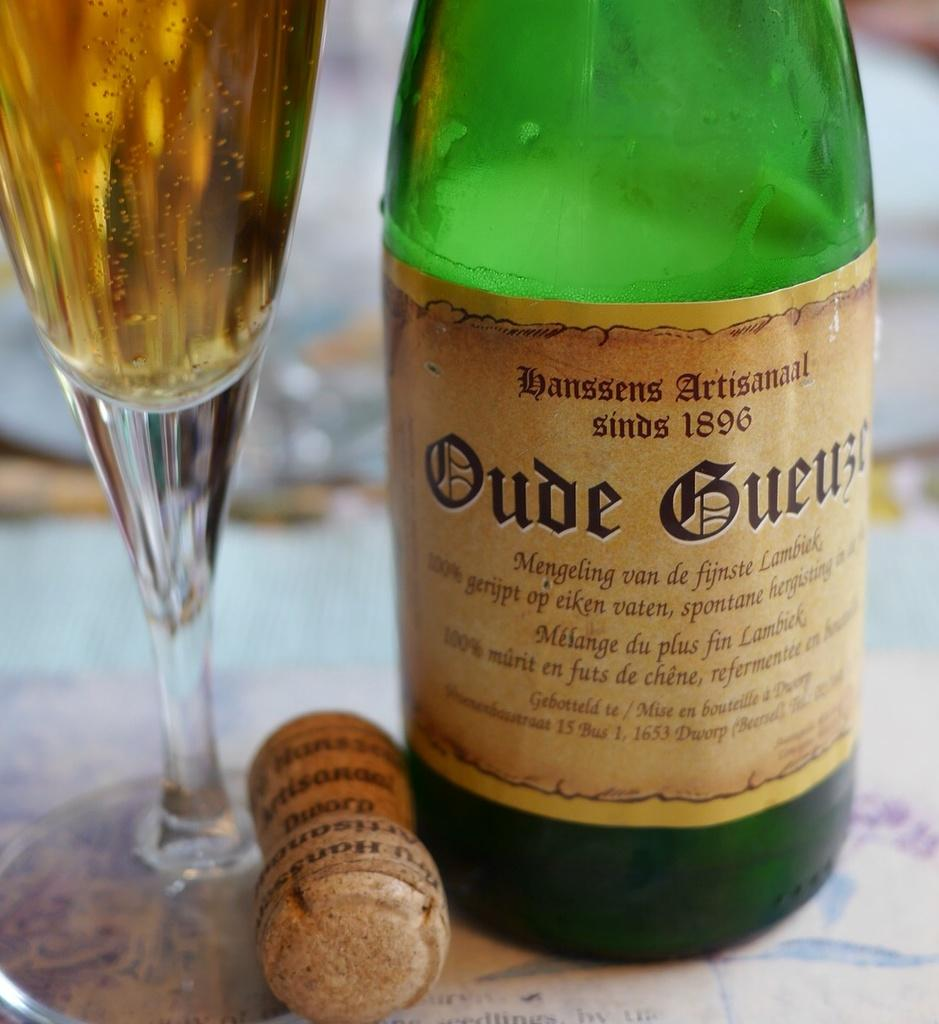<image>
Share a concise interpretation of the image provided. A bottle of alcohol whose brand was established in 1896. 